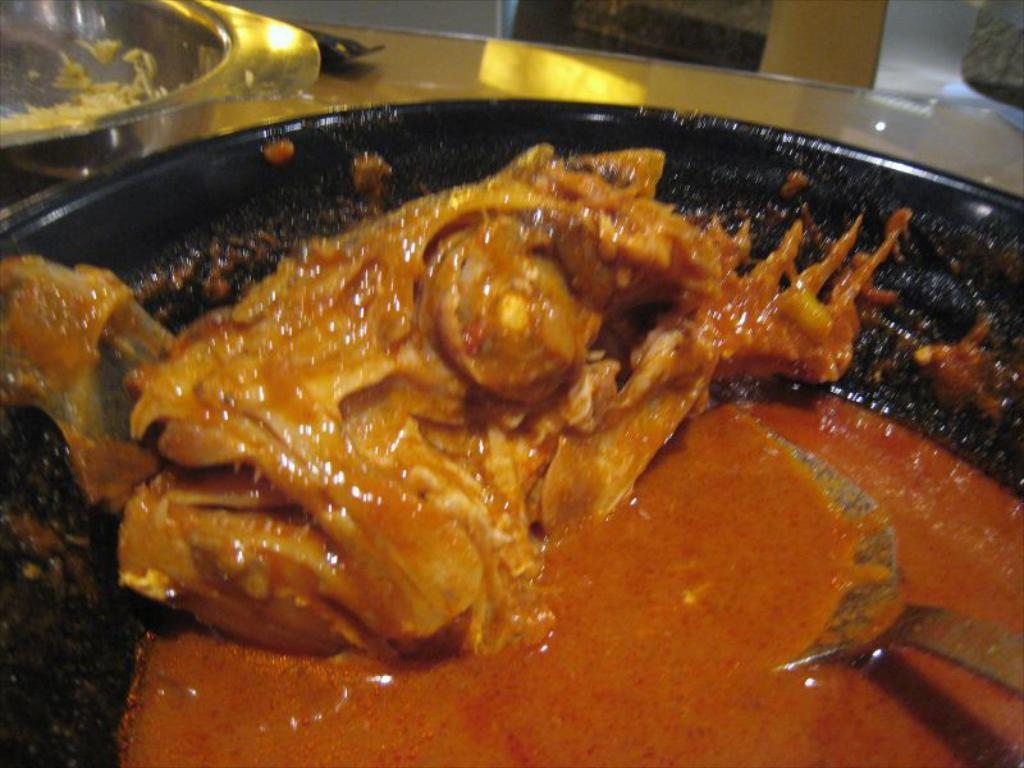What type of food item is present in the image? There is a food item in the image, but the specific type cannot be determined from the provided facts. What utensil is present in the image? There is a spoon in the image. Where is the spoon located? The spoon is in a bowl. What else can be seen in the image besides the food item and spoon? There are other objects visible in the background of the image, but their specific nature cannot be determined from the provided facts. How many dolls are sitting on the bike in the image? There are no dolls or bikes present in the image. 